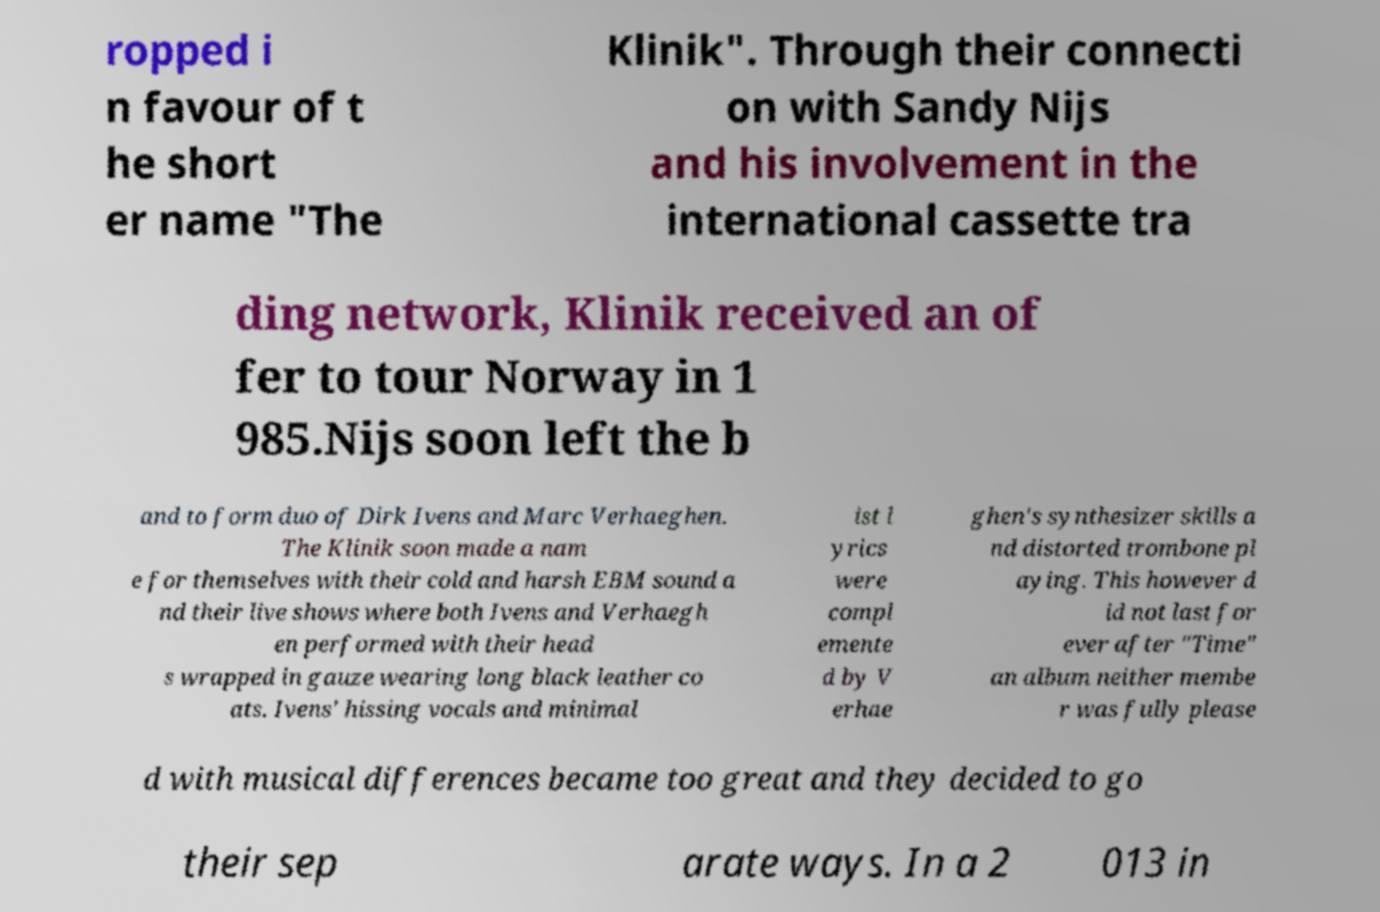Could you extract and type out the text from this image? ropped i n favour of t he short er name "The Klinik". Through their connecti on with Sandy Nijs and his involvement in the international cassette tra ding network, Klinik received an of fer to tour Norway in 1 985.Nijs soon left the b and to form duo of Dirk Ivens and Marc Verhaeghen. The Klinik soon made a nam e for themselves with their cold and harsh EBM sound a nd their live shows where both Ivens and Verhaegh en performed with their head s wrapped in gauze wearing long black leather co ats. Ivens' hissing vocals and minimal ist l yrics were compl emente d by V erhae ghen's synthesizer skills a nd distorted trombone pl aying. This however d id not last for ever after "Time" an album neither membe r was fully please d with musical differences became too great and they decided to go their sep arate ways. In a 2 013 in 